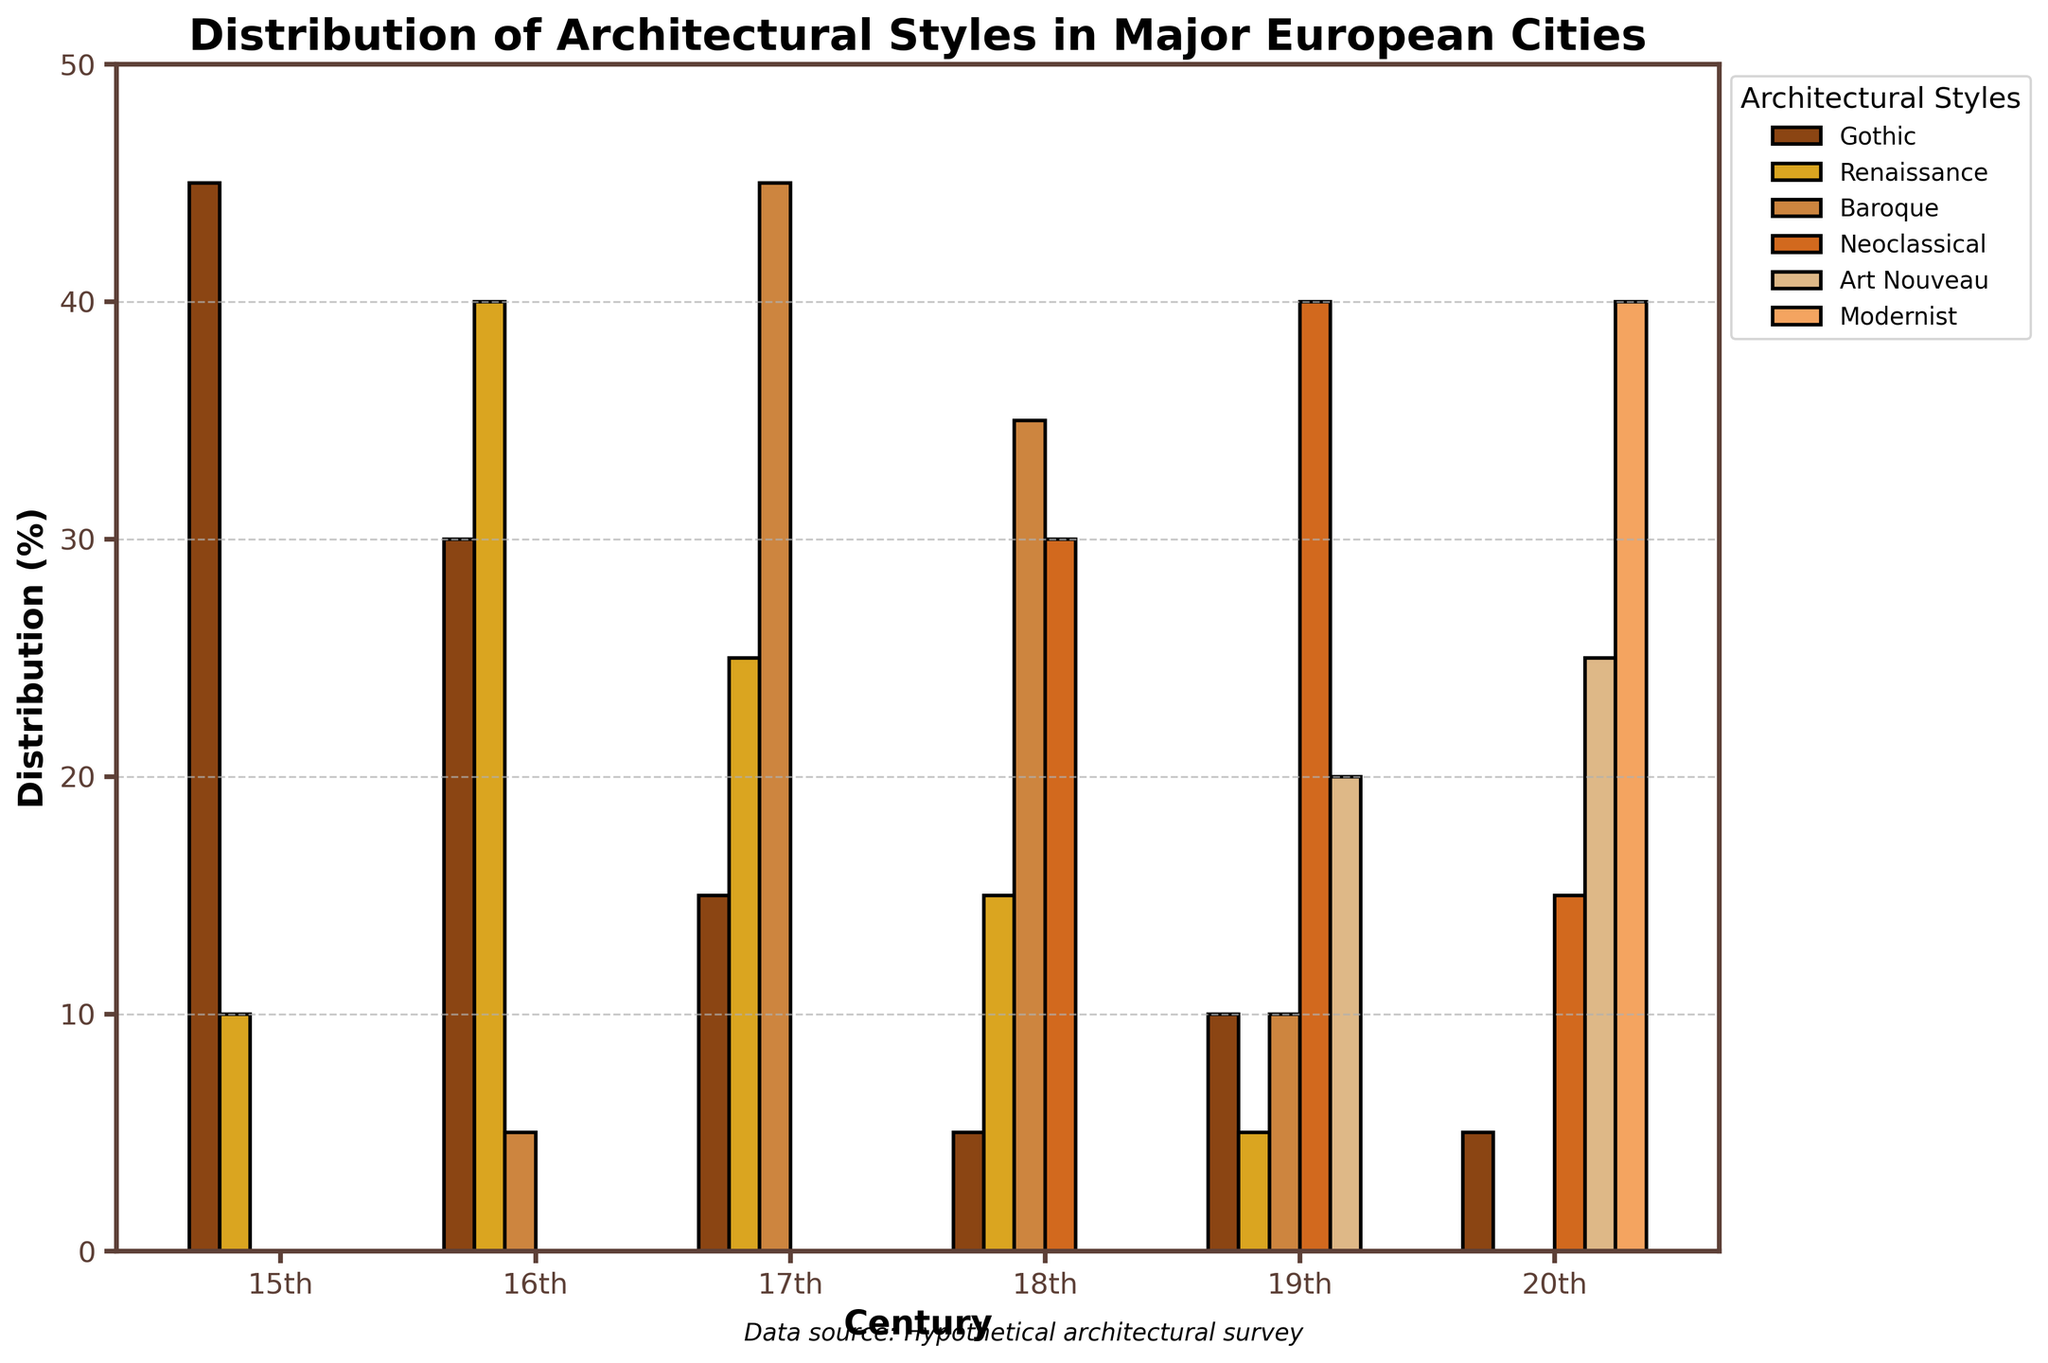Which architectural style saw the highest representation in the 18th century? To find this, look at the bars labeled as "18th" under each architectural style. The Neoclassical style has the highest bar.
Answer: Neoclassical Which century has the most diverse distribution of architectural styles? To answer this, observe which century has bars of fairly equal or varied heights. The 19th century shows a relatively even distribution among Gothic, Renaissance, Baroque, Neoclassical, and Art Nouveau styles.
Answer: 19th century How did the representation of Gothic architecture change from the 15th century to the 17th century? Compare the height of the Gothic bars in the 15th, 16th, and 17th centuries. The representation decreased from 45% in the 15th century, to 30% in the 16th century, and further to 15% in the 17th century.
Answer: Decreased Which two architectural styles together make up the highest percentage in the 17th century? Look at the total height of the bars for the 17th century. The Baroque and Renaissance styles together make up 45% + 25% = 70%, which is the highest combination.
Answer: Baroque and Renaissance What is the difference in the distribution percentage of Art Nouveau and Modernist styles in the 20th century? Find the height of the bars for Art Nouveau and Modernist in the 20th century and subtract them. 40% (Modernist) - 25% (Art Nouveau) = 15%.
Answer: 15% In which century did the Baroque style first reach more than 30% distribution? Identify the first century where the Baroque bar height is more than 30%. This occurs in the 17th century where the Baroque style is at 45%.
Answer: 17th century Which architectural style shows the most significant increase from the 19th to the 20th century? Observe the bars for each style in the 19th and 20th centuries. The Modernist style increases from 0% in the 19th century to 40% in the 20th century, showing the most significant increase.
Answer: Modernist 